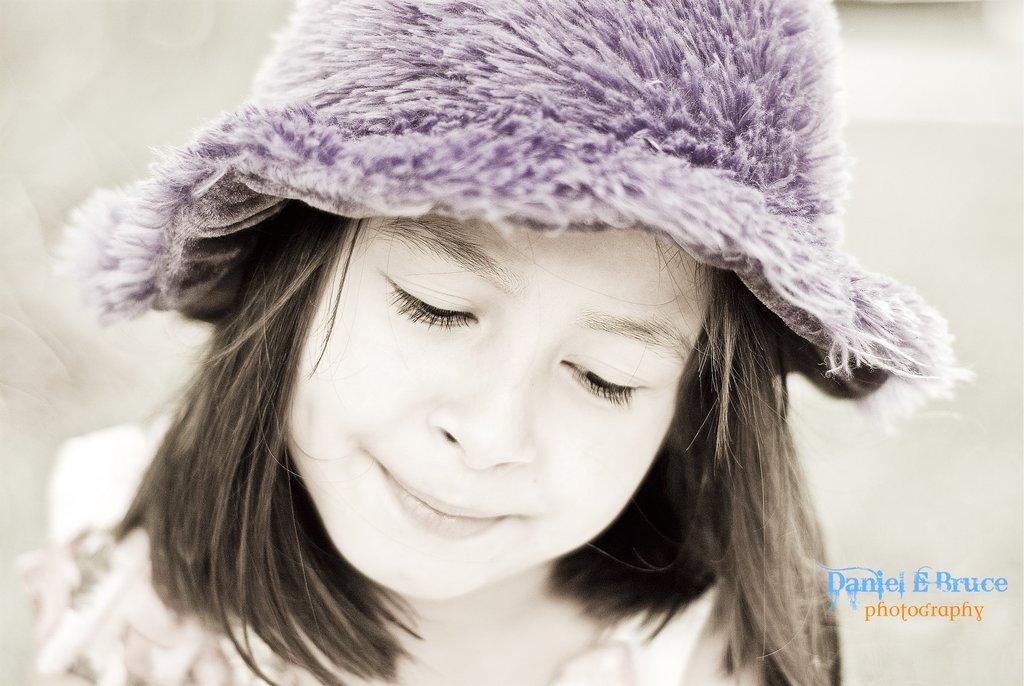In one or two sentences, can you explain what this image depicts? In this image we can see a girl wearing a violet color cap and short hair. A text was written on the image. 